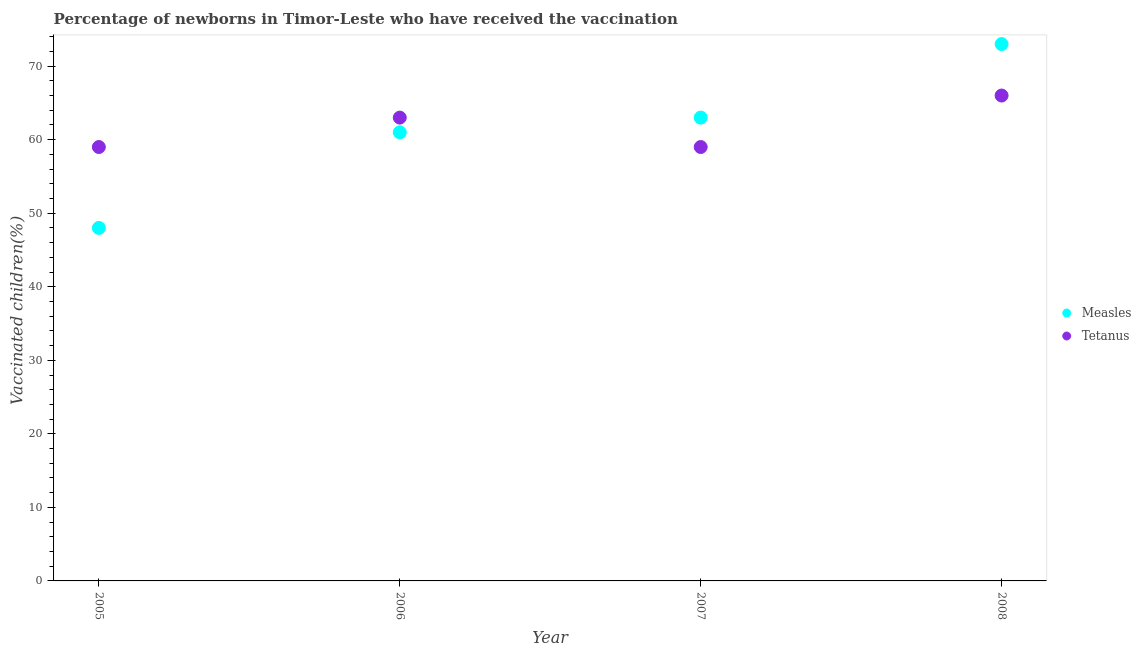Is the number of dotlines equal to the number of legend labels?
Make the answer very short. Yes. What is the percentage of newborns who received vaccination for tetanus in 2007?
Provide a succinct answer. 59. Across all years, what is the maximum percentage of newborns who received vaccination for tetanus?
Offer a very short reply. 66. Across all years, what is the minimum percentage of newborns who received vaccination for tetanus?
Offer a very short reply. 59. In which year was the percentage of newborns who received vaccination for tetanus maximum?
Keep it short and to the point. 2008. In which year was the percentage of newborns who received vaccination for tetanus minimum?
Provide a short and direct response. 2005. What is the total percentage of newborns who received vaccination for measles in the graph?
Offer a very short reply. 245. What is the difference between the percentage of newborns who received vaccination for measles in 2007 and the percentage of newborns who received vaccination for tetanus in 2008?
Your response must be concise. -3. What is the average percentage of newborns who received vaccination for tetanus per year?
Keep it short and to the point. 61.75. In the year 2007, what is the difference between the percentage of newborns who received vaccination for measles and percentage of newborns who received vaccination for tetanus?
Your answer should be very brief. 4. What is the ratio of the percentage of newborns who received vaccination for tetanus in 2007 to that in 2008?
Offer a terse response. 0.89. Is the difference between the percentage of newborns who received vaccination for measles in 2005 and 2008 greater than the difference between the percentage of newborns who received vaccination for tetanus in 2005 and 2008?
Your answer should be compact. No. What is the difference between the highest and the lowest percentage of newborns who received vaccination for measles?
Make the answer very short. 25. In how many years, is the percentage of newborns who received vaccination for measles greater than the average percentage of newborns who received vaccination for measles taken over all years?
Make the answer very short. 2. Is the sum of the percentage of newborns who received vaccination for tetanus in 2005 and 2007 greater than the maximum percentage of newborns who received vaccination for measles across all years?
Your answer should be compact. Yes. Does the percentage of newborns who received vaccination for measles monotonically increase over the years?
Keep it short and to the point. Yes. Is the percentage of newborns who received vaccination for tetanus strictly less than the percentage of newborns who received vaccination for measles over the years?
Provide a succinct answer. No. How many dotlines are there?
Offer a terse response. 2. Are the values on the major ticks of Y-axis written in scientific E-notation?
Provide a short and direct response. No. Does the graph contain any zero values?
Offer a terse response. No. How many legend labels are there?
Offer a very short reply. 2. How are the legend labels stacked?
Offer a terse response. Vertical. What is the title of the graph?
Provide a short and direct response. Percentage of newborns in Timor-Leste who have received the vaccination. What is the label or title of the Y-axis?
Ensure brevity in your answer.  Vaccinated children(%)
. What is the Vaccinated children(%)
 in Measles in 2005?
Ensure brevity in your answer.  48. What is the Vaccinated children(%)
 in Measles in 2006?
Make the answer very short. 61. What is the Vaccinated children(%)
 of Tetanus in 2006?
Provide a short and direct response. 63. What is the Vaccinated children(%)
 of Measles in 2007?
Your answer should be very brief. 63. What is the Vaccinated children(%)
 in Tetanus in 2007?
Offer a very short reply. 59. What is the Vaccinated children(%)
 of Tetanus in 2008?
Provide a succinct answer. 66. Across all years, what is the minimum Vaccinated children(%)
 in Tetanus?
Your answer should be compact. 59. What is the total Vaccinated children(%)
 of Measles in the graph?
Ensure brevity in your answer.  245. What is the total Vaccinated children(%)
 in Tetanus in the graph?
Make the answer very short. 247. What is the difference between the Vaccinated children(%)
 of Tetanus in 2005 and that in 2007?
Give a very brief answer. 0. What is the difference between the Vaccinated children(%)
 in Tetanus in 2005 and that in 2008?
Offer a very short reply. -7. What is the difference between the Vaccinated children(%)
 of Measles in 2006 and that in 2007?
Provide a short and direct response. -2. What is the difference between the Vaccinated children(%)
 in Tetanus in 2006 and that in 2007?
Give a very brief answer. 4. What is the difference between the Vaccinated children(%)
 in Measles in 2007 and that in 2008?
Provide a succinct answer. -10. What is the difference between the Vaccinated children(%)
 in Tetanus in 2007 and that in 2008?
Your answer should be very brief. -7. What is the difference between the Vaccinated children(%)
 in Measles in 2005 and the Vaccinated children(%)
 in Tetanus in 2006?
Your answer should be very brief. -15. What is the difference between the Vaccinated children(%)
 in Measles in 2005 and the Vaccinated children(%)
 in Tetanus in 2007?
Provide a succinct answer. -11. What is the difference between the Vaccinated children(%)
 in Measles in 2006 and the Vaccinated children(%)
 in Tetanus in 2008?
Your response must be concise. -5. What is the average Vaccinated children(%)
 of Measles per year?
Keep it short and to the point. 61.25. What is the average Vaccinated children(%)
 in Tetanus per year?
Provide a short and direct response. 61.75. In the year 2007, what is the difference between the Vaccinated children(%)
 in Measles and Vaccinated children(%)
 in Tetanus?
Provide a short and direct response. 4. What is the ratio of the Vaccinated children(%)
 of Measles in 2005 to that in 2006?
Offer a very short reply. 0.79. What is the ratio of the Vaccinated children(%)
 in Tetanus in 2005 to that in 2006?
Keep it short and to the point. 0.94. What is the ratio of the Vaccinated children(%)
 of Measles in 2005 to that in 2007?
Give a very brief answer. 0.76. What is the ratio of the Vaccinated children(%)
 of Tetanus in 2005 to that in 2007?
Your response must be concise. 1. What is the ratio of the Vaccinated children(%)
 of Measles in 2005 to that in 2008?
Give a very brief answer. 0.66. What is the ratio of the Vaccinated children(%)
 in Tetanus in 2005 to that in 2008?
Keep it short and to the point. 0.89. What is the ratio of the Vaccinated children(%)
 in Measles in 2006 to that in 2007?
Offer a terse response. 0.97. What is the ratio of the Vaccinated children(%)
 in Tetanus in 2006 to that in 2007?
Make the answer very short. 1.07. What is the ratio of the Vaccinated children(%)
 in Measles in 2006 to that in 2008?
Your answer should be very brief. 0.84. What is the ratio of the Vaccinated children(%)
 in Tetanus in 2006 to that in 2008?
Ensure brevity in your answer.  0.95. What is the ratio of the Vaccinated children(%)
 in Measles in 2007 to that in 2008?
Make the answer very short. 0.86. What is the ratio of the Vaccinated children(%)
 of Tetanus in 2007 to that in 2008?
Provide a succinct answer. 0.89. What is the difference between the highest and the lowest Vaccinated children(%)
 of Measles?
Your answer should be compact. 25. 